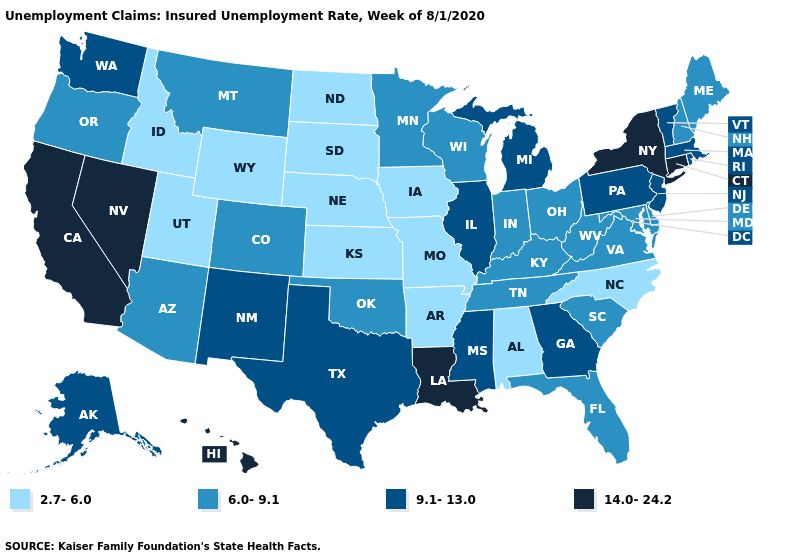Name the states that have a value in the range 9.1-13.0?
Be succinct. Alaska, Georgia, Illinois, Massachusetts, Michigan, Mississippi, New Jersey, New Mexico, Pennsylvania, Rhode Island, Texas, Vermont, Washington. Among the states that border Florida , which have the highest value?
Concise answer only. Georgia. Does the map have missing data?
Keep it brief. No. Name the states that have a value in the range 2.7-6.0?
Keep it brief. Alabama, Arkansas, Idaho, Iowa, Kansas, Missouri, Nebraska, North Carolina, North Dakota, South Dakota, Utah, Wyoming. Among the states that border Louisiana , which have the lowest value?
Write a very short answer. Arkansas. Does the first symbol in the legend represent the smallest category?
Short answer required. Yes. Does the map have missing data?
Short answer required. No. What is the value of Arizona?
Short answer required. 6.0-9.1. What is the value of Minnesota?
Keep it brief. 6.0-9.1. What is the value of Arkansas?
Be succinct. 2.7-6.0. Name the states that have a value in the range 6.0-9.1?
Give a very brief answer. Arizona, Colorado, Delaware, Florida, Indiana, Kentucky, Maine, Maryland, Minnesota, Montana, New Hampshire, Ohio, Oklahoma, Oregon, South Carolina, Tennessee, Virginia, West Virginia, Wisconsin. What is the value of New York?
Give a very brief answer. 14.0-24.2. What is the value of South Dakota?
Quick response, please. 2.7-6.0. Does the first symbol in the legend represent the smallest category?
Quick response, please. Yes. Name the states that have a value in the range 9.1-13.0?
Short answer required. Alaska, Georgia, Illinois, Massachusetts, Michigan, Mississippi, New Jersey, New Mexico, Pennsylvania, Rhode Island, Texas, Vermont, Washington. 